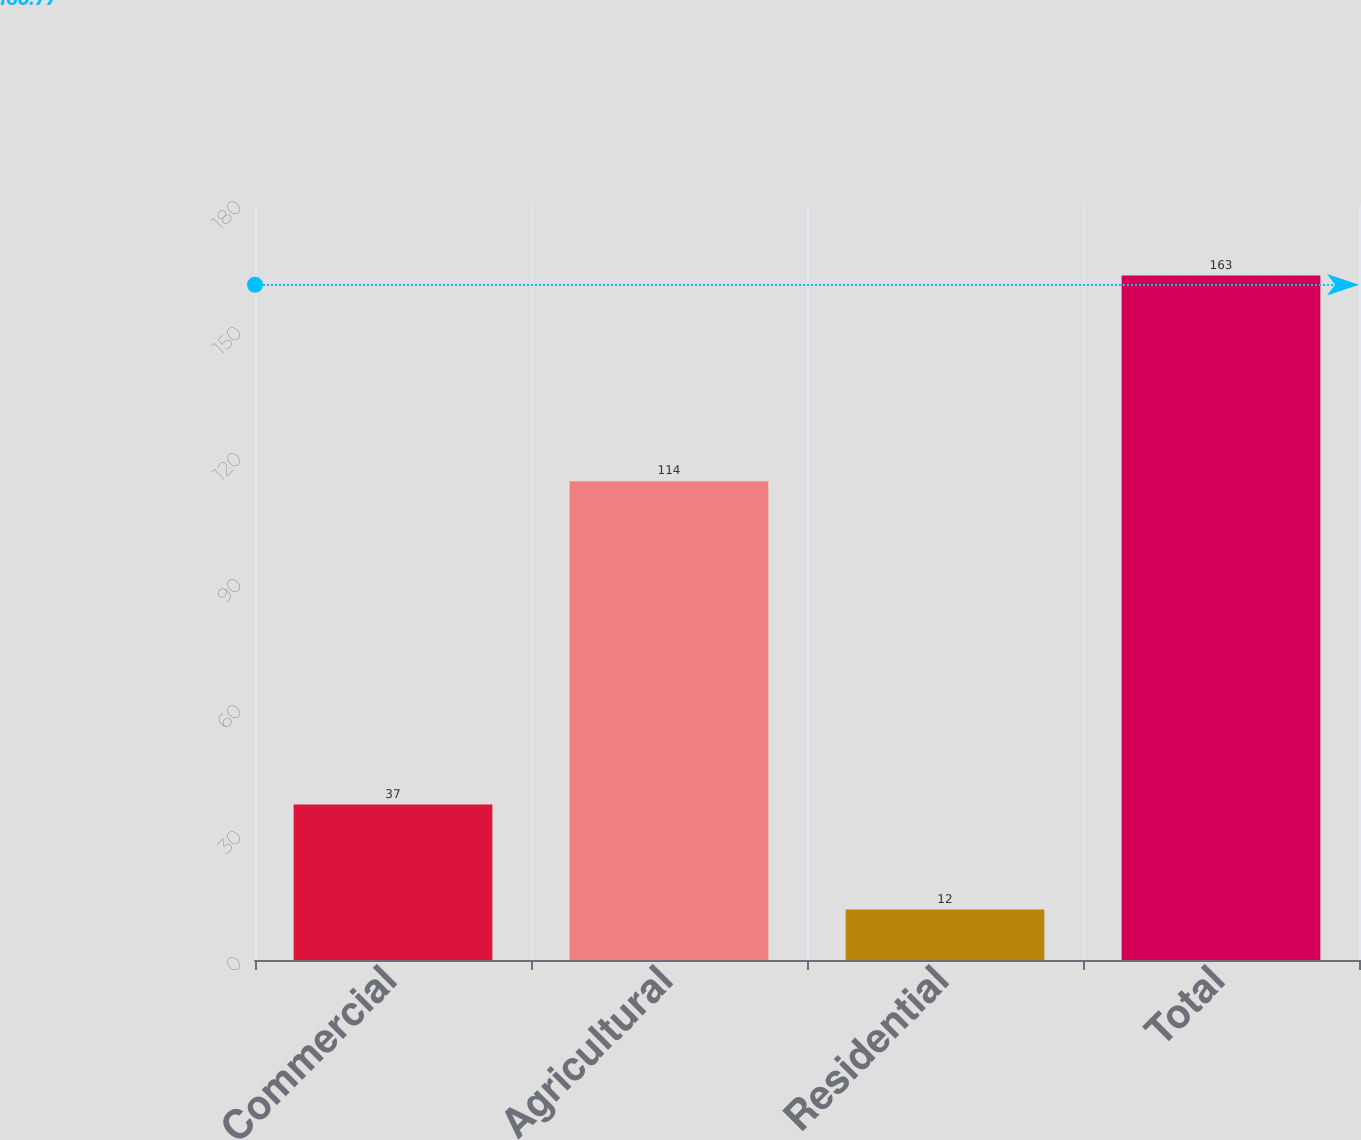Convert chart. <chart><loc_0><loc_0><loc_500><loc_500><bar_chart><fcel>Commercial<fcel>Agricultural<fcel>Residential<fcel>Total<nl><fcel>37<fcel>114<fcel>12<fcel>163<nl></chart> 